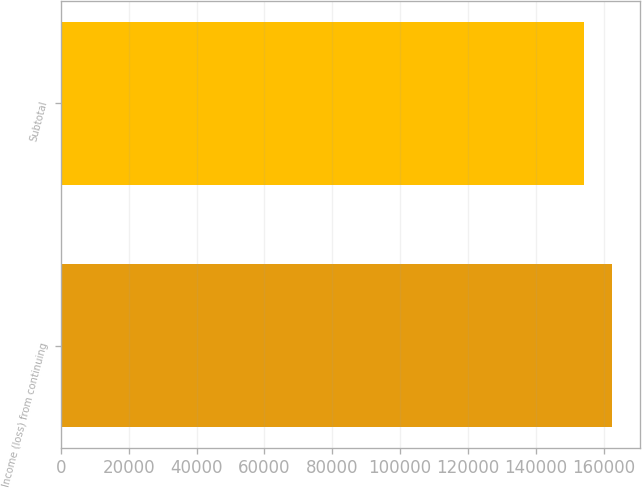<chart> <loc_0><loc_0><loc_500><loc_500><bar_chart><fcel>Income (loss) from continuing<fcel>Subtotal<nl><fcel>162589<fcel>154355<nl></chart> 